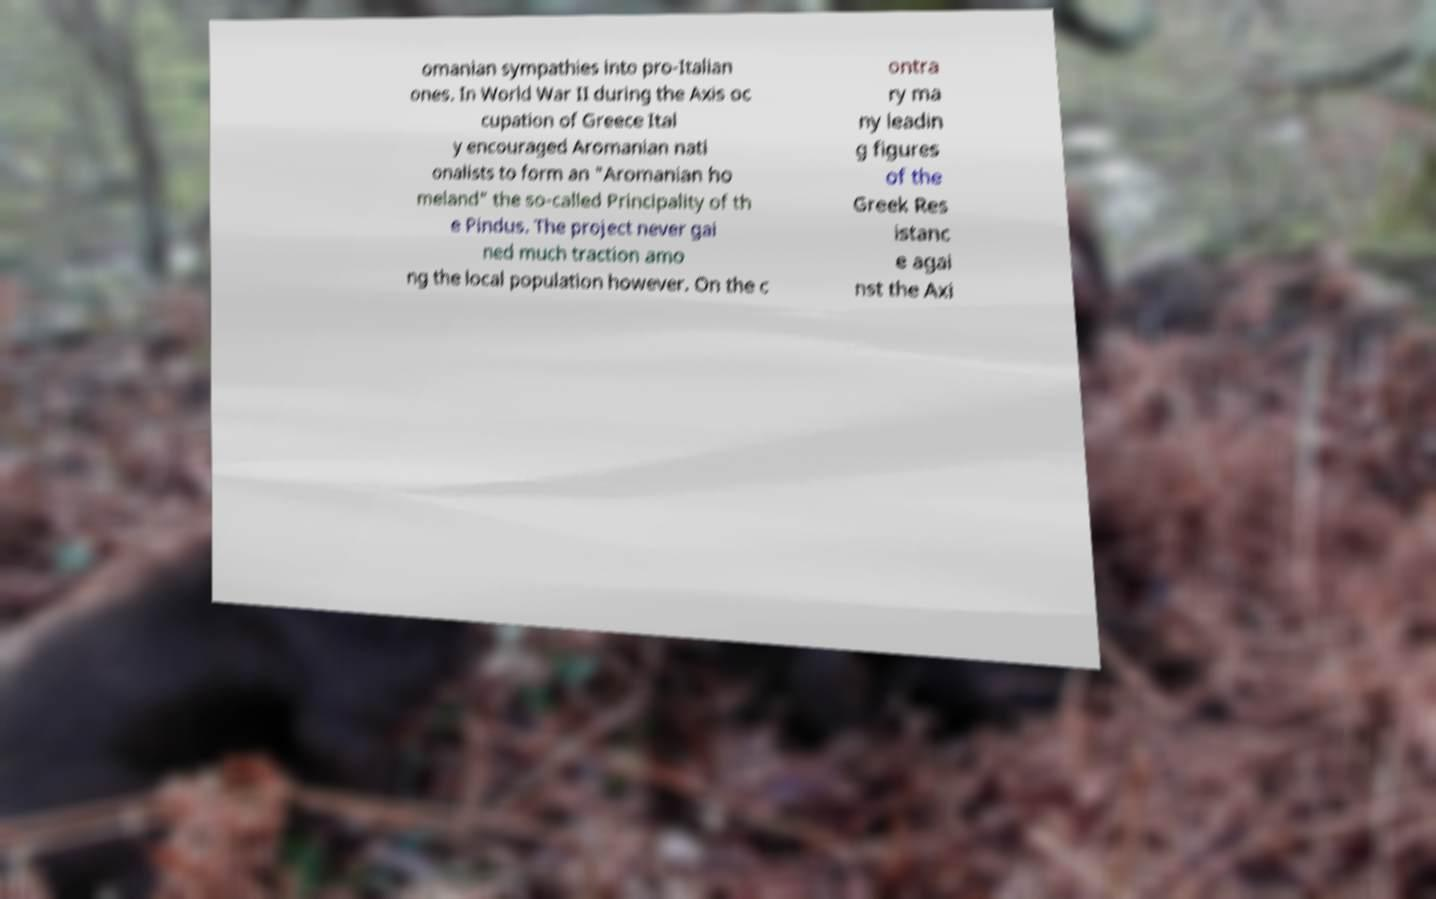What messages or text are displayed in this image? I need them in a readable, typed format. omanian sympathies into pro-Italian ones. In World War II during the Axis oc cupation of Greece Ital y encouraged Aromanian nati onalists to form an "Aromanian ho meland" the so-called Principality of th e Pindus. The project never gai ned much traction amo ng the local population however. On the c ontra ry ma ny leadin g figures of the Greek Res istanc e agai nst the Axi 